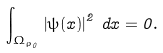<formula> <loc_0><loc_0><loc_500><loc_500>\int _ { \Omega _ { \rho _ { 0 } } } \left | \psi ( x ) \right | ^ { 2 } \, d x = 0 .</formula> 